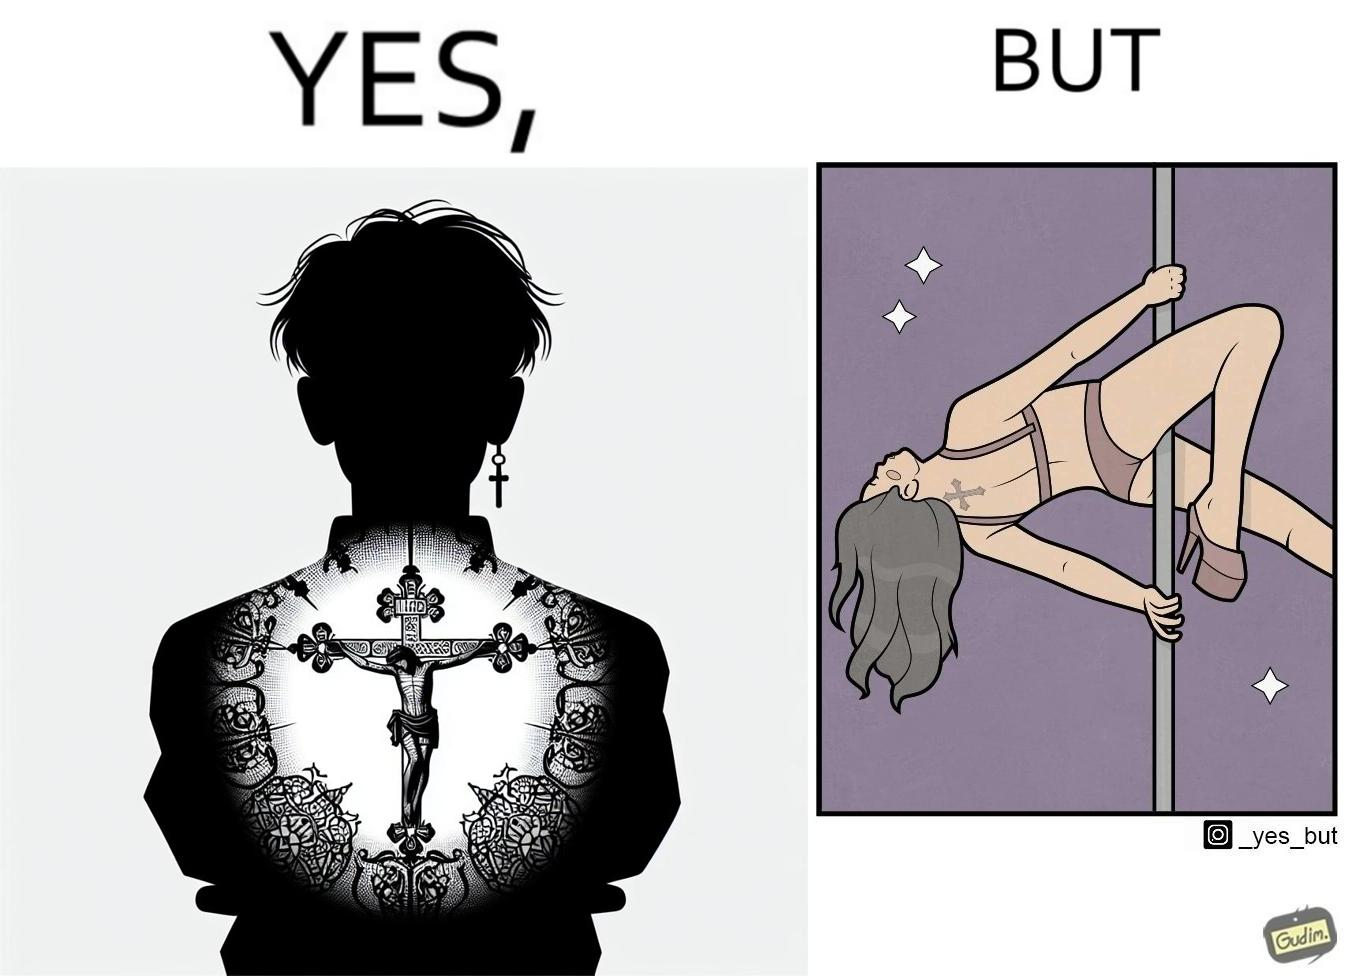Is this image satirical or non-satirical? Yes, this image is satirical. 